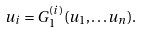<formula> <loc_0><loc_0><loc_500><loc_500>u _ { i } = G _ { 1 } ^ { ( i ) } ( u _ { 1 } , \dots u _ { n } ) .</formula> 